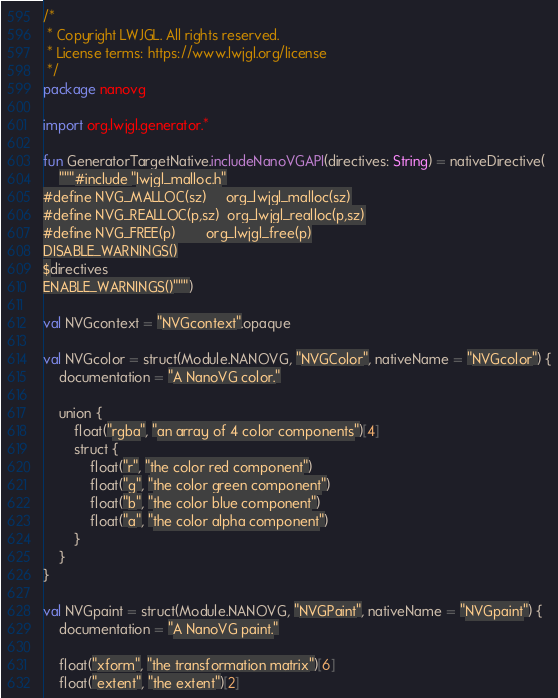<code> <loc_0><loc_0><loc_500><loc_500><_Kotlin_>/*
 * Copyright LWJGL. All rights reserved.
 * License terms: https://www.lwjgl.org/license
 */
package nanovg

import org.lwjgl.generator.*

fun GeneratorTargetNative.includeNanoVGAPI(directives: String) = nativeDirective(
    """#include "lwjgl_malloc.h"
#define NVG_MALLOC(sz)     org_lwjgl_malloc(sz)
#define NVG_REALLOC(p,sz)  org_lwjgl_realloc(p,sz)
#define NVG_FREE(p)        org_lwjgl_free(p)
DISABLE_WARNINGS()
$directives
ENABLE_WARNINGS()""")

val NVGcontext = "NVGcontext".opaque

val NVGcolor = struct(Module.NANOVG, "NVGColor", nativeName = "NVGcolor") {
    documentation = "A NanoVG color."

    union {
        float("rgba", "an array of 4 color components")[4]
        struct {
            float("r", "the color red component")
            float("g", "the color green component")
            float("b", "the color blue component")
            float("a", "the color alpha component")
        }
    }
}

val NVGpaint = struct(Module.NANOVG, "NVGPaint", nativeName = "NVGpaint") {
    documentation = "A NanoVG paint."

    float("xform", "the transformation matrix")[6]
    float("extent", "the extent")[2]</code> 